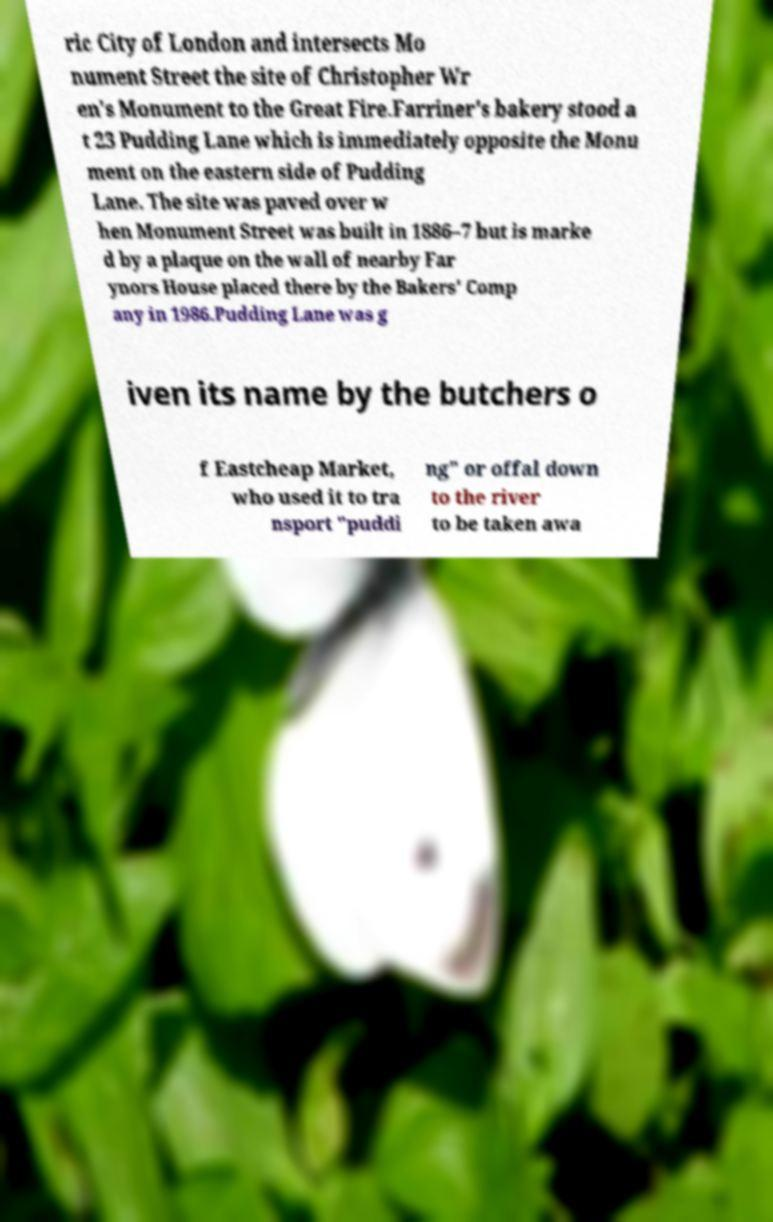Could you extract and type out the text from this image? ric City of London and intersects Mo nument Street the site of Christopher Wr en's Monument to the Great Fire.Farriner's bakery stood a t 23 Pudding Lane which is immediately opposite the Monu ment on the eastern side of Pudding Lane. The site was paved over w hen Monument Street was built in 1886–7 but is marke d by a plaque on the wall of nearby Far ynors House placed there by the Bakers' Comp any in 1986.Pudding Lane was g iven its name by the butchers o f Eastcheap Market, who used it to tra nsport "puddi ng" or offal down to the river to be taken awa 